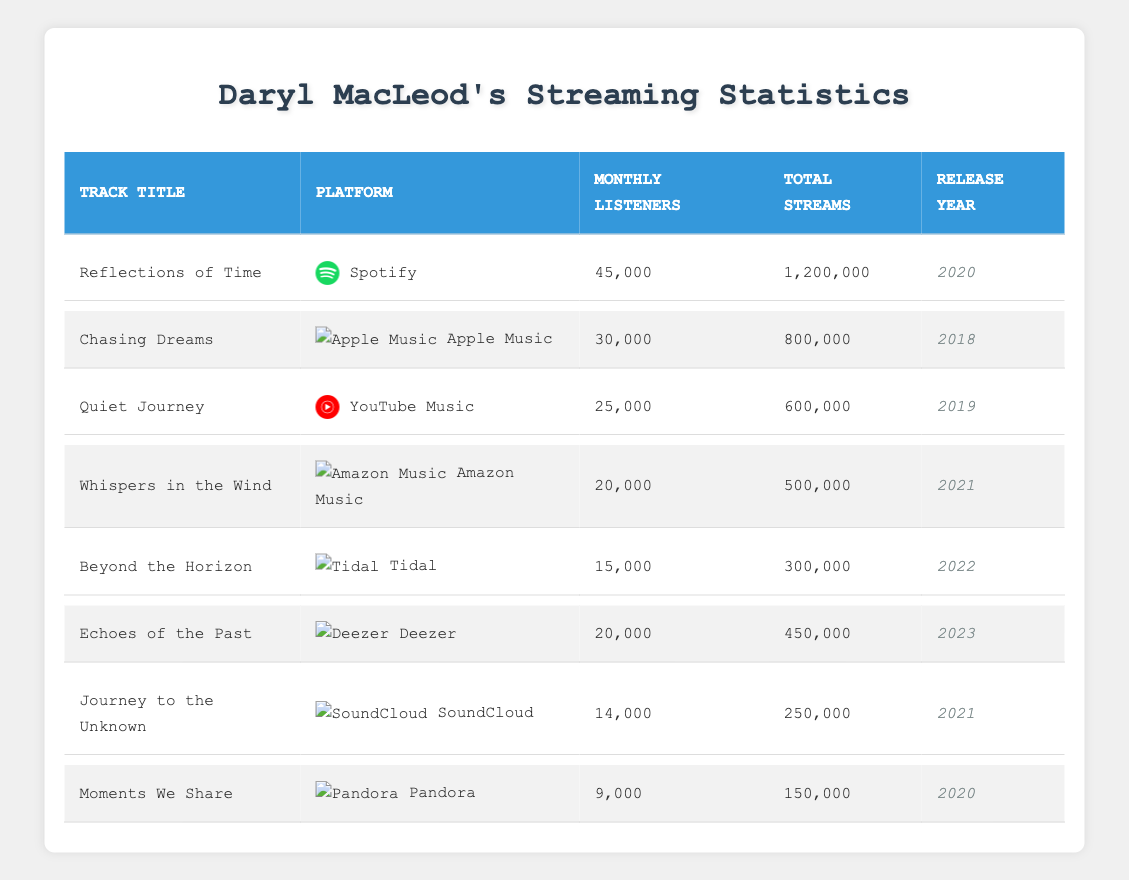What is the total number of streams for "Reflections of Time"? The total number of streams is listed under the "Total Streams" column for "Reflections of Time," which shows 1,200,000.
Answer: 1,200,000 Which track has the highest number of monthly listeners? By comparing the "Monthly Listeners" column, "Reflections of Time" has the highest number with 45,000 monthly listeners.
Answer: "Reflections of Time" Is "Beyond the Horizon" the only track released in 2022? Yes, examining the "Release Year" column shows that "Beyond the Horizon" is the only entry with the release year 2022.
Answer: Yes What is the average number of monthly listeners for all tracks? To find the average, sum the monthly listeners: 45000 + 30000 + 25000 + 20000 + 15000 + 20000 + 14000 + 9000 = 1,615,000. Then, divide by 8 (the number of tracks): 1,615,000 / 8 = 201,875. Therefore, the average is 20,187.5.
Answer: 20,187.5 How many tracks have more than 20,000 monthly listeners? By examining the "Monthly Listeners" column, the tracks with more than 20,000 monthly listeners are: "Reflections of Time," "Chasing Dreams," and "Quiet Journey." That's 3 tracks.
Answer: 3 What is the total number of streams for the tracks released before 2021? The tracks released before 2021 are "Chasing Dreams," "Quiet Journey," and "Moments We Share." Their total streams are 800,000 + 600,000 + 150,000 = 1,550,000.
Answer: 1,550,000 Is "Echoes of the Past" available on more than one streaming platform? No, "Echoes of the Past" is listed as being available only on Deezer according to the table.
Answer: No Which track has the lowest total streams and what is that number? "Moments We Share" has the lowest total streams with a total of 150,000.
Answer: 150,000 What percentage of the total number of monthly listeners does "Whispers in the Wind" have? The total monthly listeners for all tracks is 1,615,000. "Whispers in the Wind" has 20,000 monthly listeners. To find the percentage: (20,000 / 1,615,000) * 100 ≈ 1.24%.
Answer: ~1.24% Which two platforms have the highest total streams combined? The total streams for Spotify (1,200,000) and Apple Music (800,000) add up to 1,200,000 + 800,000 = 2,000,000, which is higher than any other combination of platforms.
Answer: 2,000,000 